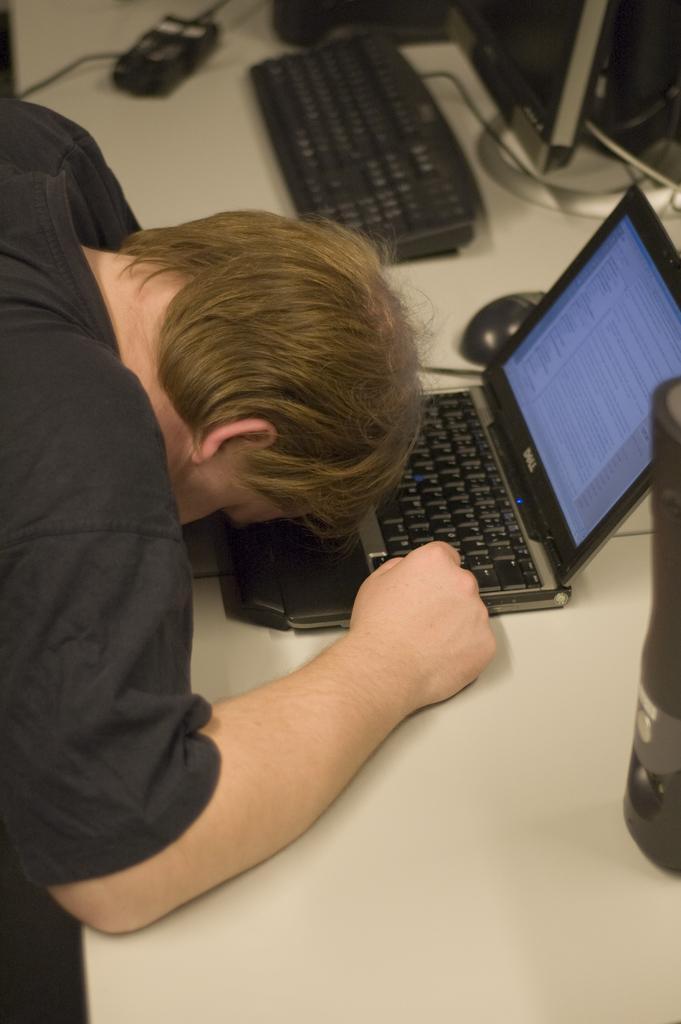Can you describe this image briefly? As we can see in the image, there is a man and the table. On table there is a bottle, laptop, mouse and keyboard. 